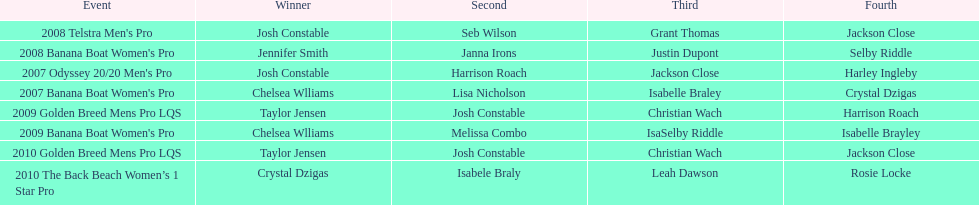What is the total number of times chelsea williams was the winner between 2007 and 2010? 2. 